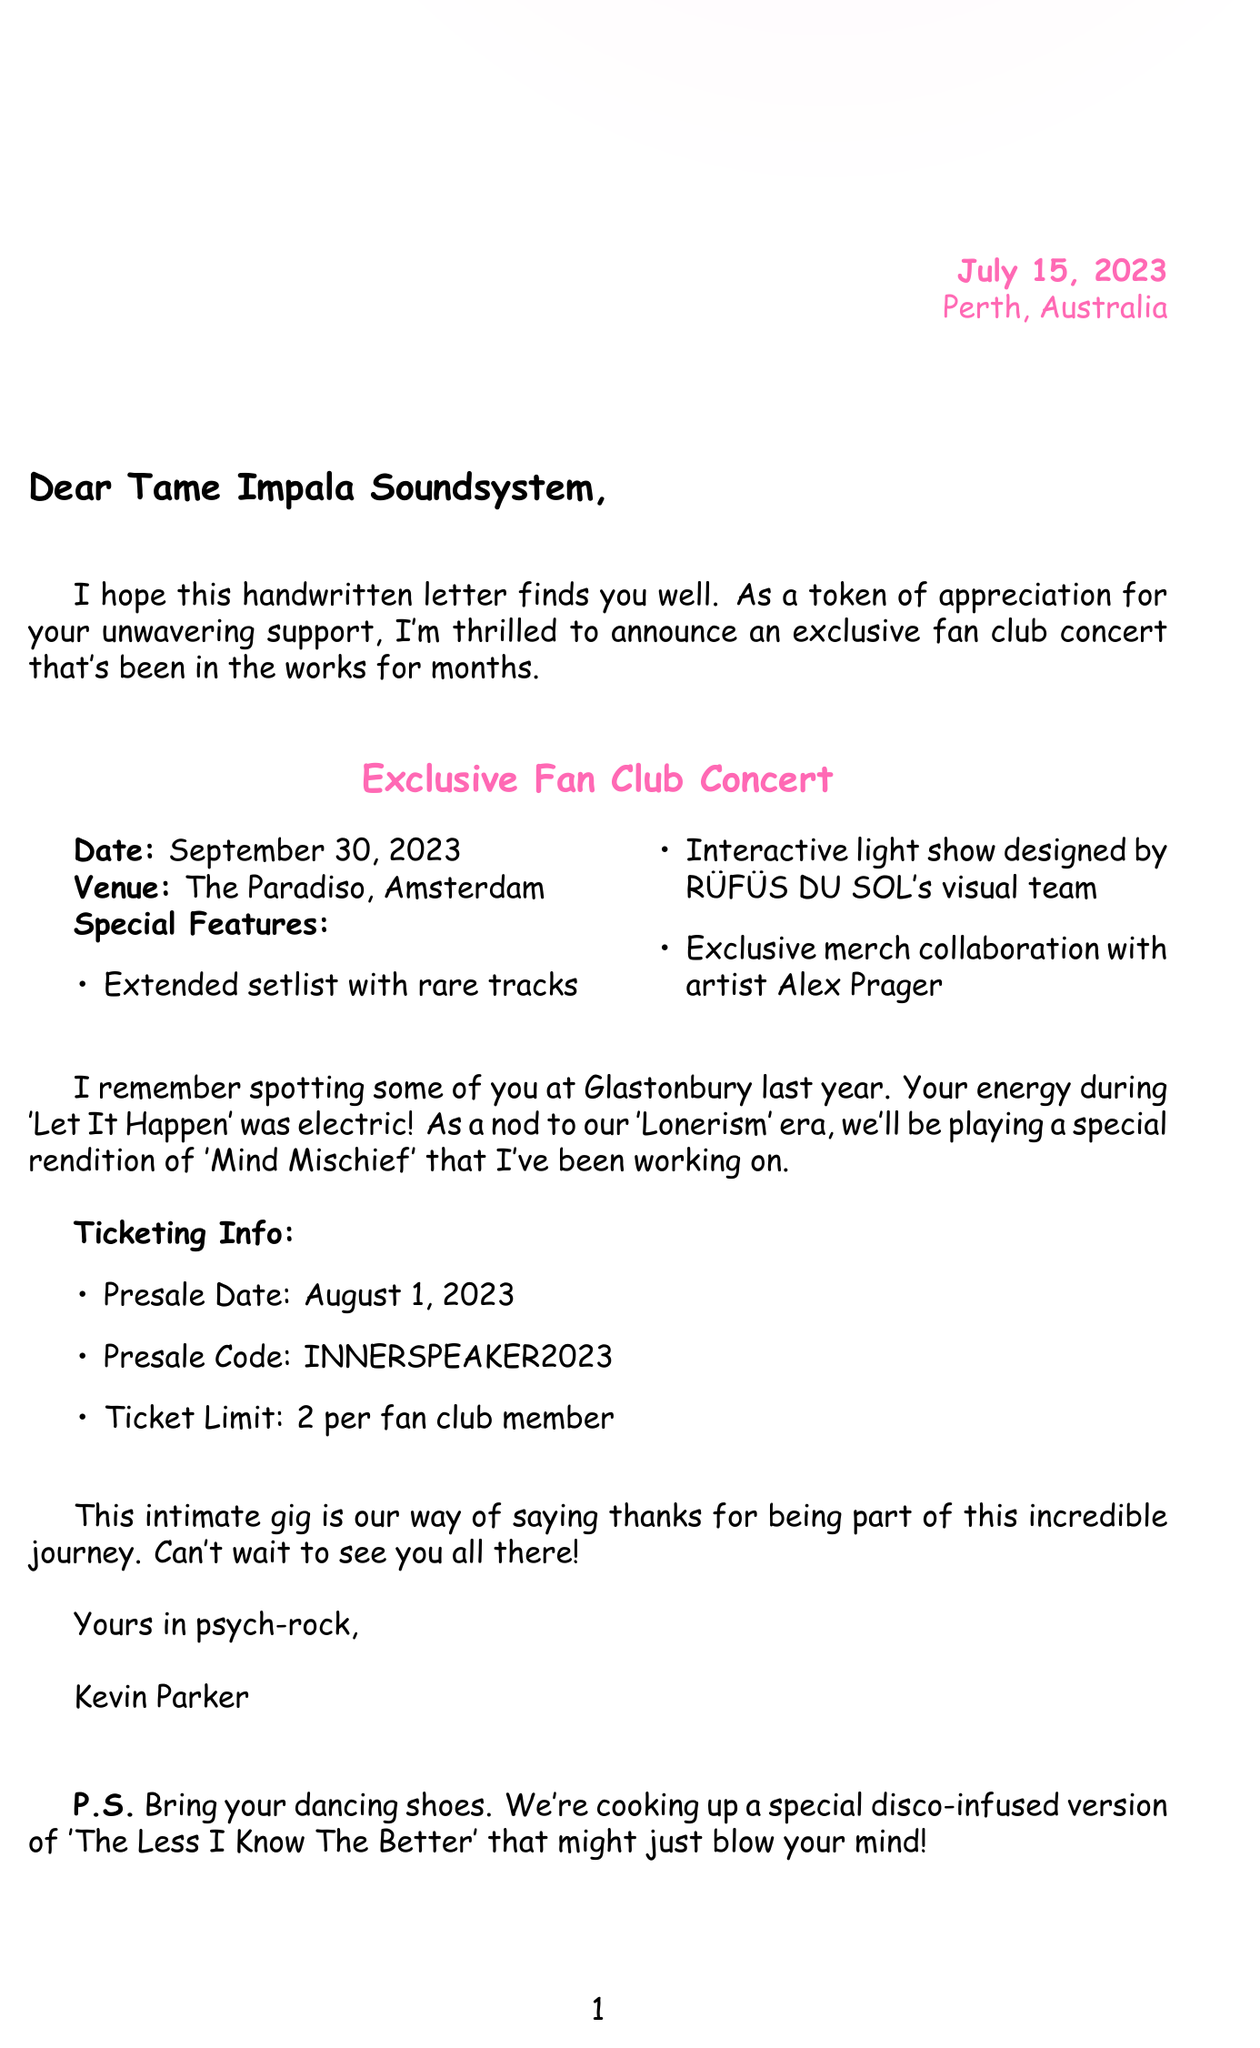What is the date of the concert? The concert is scheduled for September 30, 2023, as mentioned in the concert details section.
Answer: September 30, 2023 Where is the concert taking place? The venue for the concert is The Paradiso, which is stated in the concert details section.
Answer: The Paradiso, Amsterdam What is the presale date for tickets? The presale date for tickets is given as August 1, 2023, in the ticketing information section.
Answer: August 1, 2023 What is one of the special features of the concert? One of the special features includes an extended setlist with rare tracks, as listed in the concert details.
Answer: Extended setlist with rare tracks Who designed the interactive light show? The interactive light show was designed by RÜFÜS DU SOL's visual team, as stated in the concert details section.
Answer: RÜFÜS DU SOL's visual team What phrase does Kevin Parker use to sign off the letter? The sign off phrase used by Kevin Parker is "Yours in psych-rock," located just before his signature.
Answer: Yours in psych-rock How many tickets can a fan club member purchase? The ticket limit for fans is mentioned as 2 per fan club member in the ticketing information.
Answer: 2 per fan club member What was the emotional tone of the introduction paragraph? The emotional tone of the introduction paragraph is described as "grateful and excited."
Answer: Grateful and excited What type of sketch is included in the letter? The personalized sketch is described as a hand-drawn sketch of Kevin's iconic Rickenbacker 335 guitar.
Answer: Iconic Rickenbacker 335 guitar sketch 